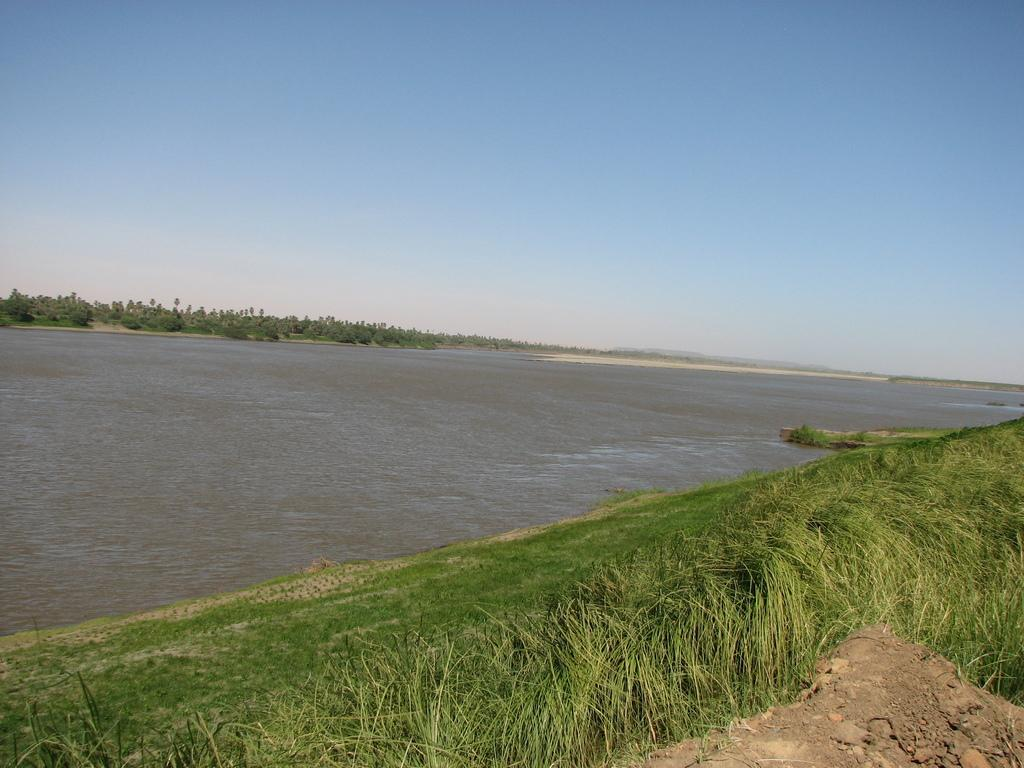What is visible in the center of the image? The sky, trees, water, and grass are visible in the center of the image. Can you describe the natural elements present in the image? The image features a combination of sky, trees, water, and grass, which are all natural elements. How many different natural elements can be seen in the image? Four different natural elements can be seen in the image: sky, trees, water, and grass. What type of writing can be seen on the trees in the image? There is no writing visible on the trees in the image. Can you tell me how many veins are present in the water in the image? There are no veins present in the water in the image, as veins are a biological feature found in living organisms and not in water. 